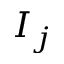Convert formula to latex. <formula><loc_0><loc_0><loc_500><loc_500>I _ { j }</formula> 